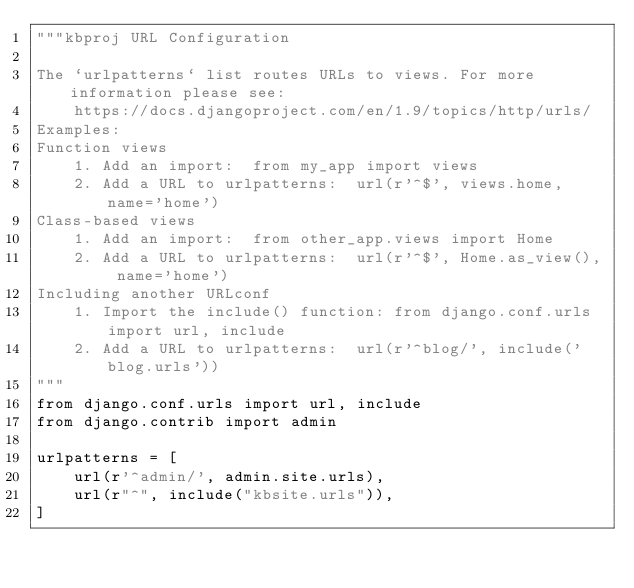Convert code to text. <code><loc_0><loc_0><loc_500><loc_500><_Python_>"""kbproj URL Configuration

The `urlpatterns` list routes URLs to views. For more information please see:
    https://docs.djangoproject.com/en/1.9/topics/http/urls/
Examples:
Function views
    1. Add an import:  from my_app import views
    2. Add a URL to urlpatterns:  url(r'^$', views.home, name='home')
Class-based views
    1. Add an import:  from other_app.views import Home
    2. Add a URL to urlpatterns:  url(r'^$', Home.as_view(), name='home')
Including another URLconf
    1. Import the include() function: from django.conf.urls import url, include
    2. Add a URL to urlpatterns:  url(r'^blog/', include('blog.urls'))
"""
from django.conf.urls import url, include
from django.contrib import admin

urlpatterns = [
    url(r'^admin/', admin.site.urls),
    url(r"^", include("kbsite.urls")),
]
</code> 